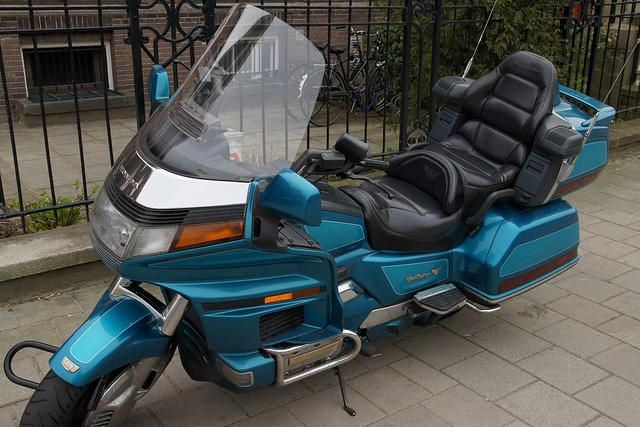How many people can ride this motorcycle at a time? Please explain your reasoning. two. Two people can be on the bike. 